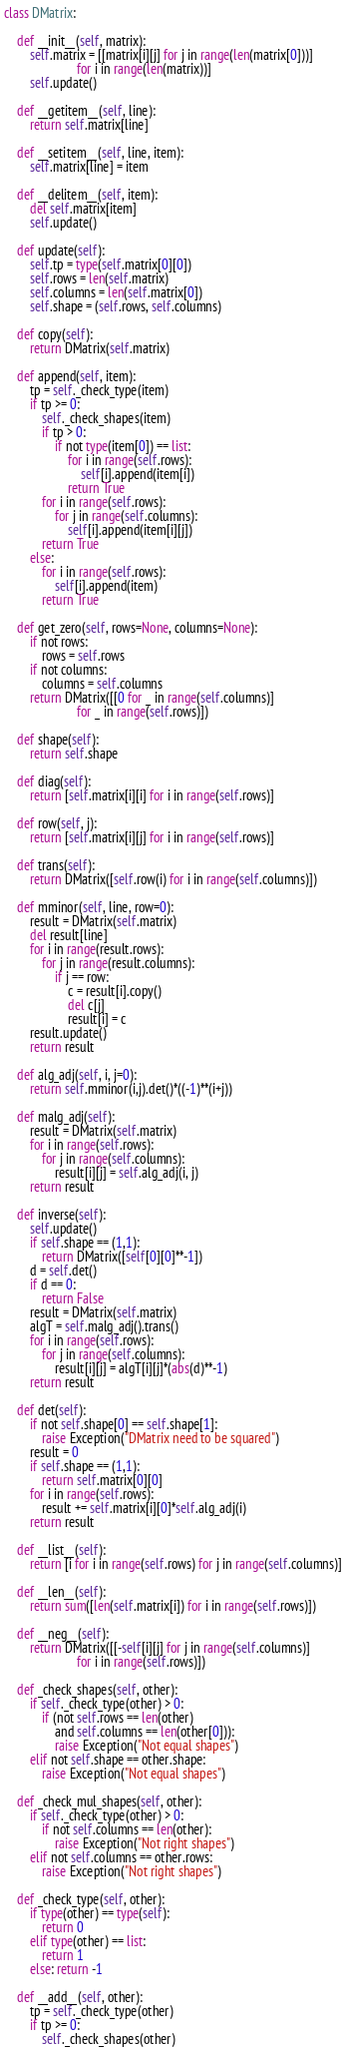Convert code to text. <code><loc_0><loc_0><loc_500><loc_500><_Python_>class DMatrix:

    def __init__(self, matrix):
        self.matrix = [[matrix[i][j] for j in range(len(matrix[0]))]
                       for i in range(len(matrix))]
        self.update()
        
    def __getitem__(self, line):
        return self.matrix[line]

    def __setitem__(self, line, item):
        self.matrix[line] = item

    def __delitem__(self, item):
        del self.matrix[item]
        self.update()

    def update(self):
        self.tp = type(self.matrix[0][0])
        self.rows = len(self.matrix)
        self.columns = len(self.matrix[0])
        self.shape = (self.rows, self.columns)

    def copy(self):
        return DMatrix(self.matrix)

    def append(self, item):
        tp = self._check_type(item)
        if tp >= 0:
            self._check_shapes(item)
            if tp > 0:
                if not type(item[0]) == list:
                    for i in range(self.rows):
                        self[i].append(item[i])
                    return True
            for i in range(self.rows):
                for j in range(self.columns):
                    self[i].append(item[i][j])
            return True
        else:
            for i in range(self.rows):
                self[i].append(item)
            return True
                
    def get_zero(self, rows=None, columns=None):
        if not rows:
            rows = self.rows
        if not columns:
            columns = self.columns
        return DMatrix([[0 for _ in range(self.columns)]
                       for _ in range(self.rows)])

    def shape(self):
        return self.shape

    def diag(self):
        return [self.matrix[i][i] for i in range(self.rows)]

    def row(self, j):
        return [self.matrix[i][j] for i in range(self.rows)]

    def trans(self):
        return DMatrix([self.row(i) for i in range(self.columns)])

    def mminor(self, line, row=0):
        result = DMatrix(self.matrix)
        del result[line]
        for i in range(result.rows):
            for j in range(result.columns):
                if j == row:
                    c = result[i].copy()
                    del c[j]
                    result[i] = c
        result.update()
        return result

    def alg_adj(self, i, j=0):
        return self.mminor(i,j).det()*((-1)**(i+j))

    def malg_adj(self):
        result = DMatrix(self.matrix)
        for i in range(self.rows):
            for j in range(self.columns):
                result[i][j] = self.alg_adj(i, j)
        return result

    def inverse(self):
        self.update()
        if self.shape == (1,1):
            return DMatrix([self[0][0]**-1])
        d = self.det()
        if d == 0:
            return False
        result = DMatrix(self.matrix)
        algT = self.malg_adj().trans()
        for i in range(self.rows):
            for j in range(self.columns):
                result[i][j] = algT[i][j]*(abs(d)**-1)
        return result

    def det(self):
        if not self.shape[0] == self.shape[1]:
            raise Exception("DMatrix need to be squared")
        result = 0
        if self.shape == (1,1):
            return self.matrix[0][0]
        for i in range(self.rows):
            result += self.matrix[i][0]*self.alg_adj(i)
        return result
    
    def __list__(self):
        return [i for i in range(self.rows) for j in range(self.columns)]

    def __len__(self):
        return sum([len(self.matrix[i]) for i in range(self.rows)]) 

    def __neg__(self):
        return DMatrix([[-self[i][j] for j in range(self.columns)]
                       for i in range(self.rows)])
    
    def _check_shapes(self, other):
        if self._check_type(other) > 0:
            if (not self.rows == len(other)
                and self.columns == len(other[0])):
                raise Exception("Not equal shapes")
        elif not self.shape == other.shape:
            raise Exception("Not equal shapes")

    def _check_mul_shapes(self, other):
        if self._check_type(other) > 0:
            if not self.columns == len(other):
                raise Exception("Not right shapes")
        elif not self.columns == other.rows:
            raise Exception("Not right shapes")

    def _check_type(self, other):
        if type(other) == type(self):
            return 0
        elif type(other) == list:
            return 1
        else: return -1
    
    def __add__(self, other):
        tp = self._check_type(other)
        if tp >= 0:
            self._check_shapes(other)</code> 